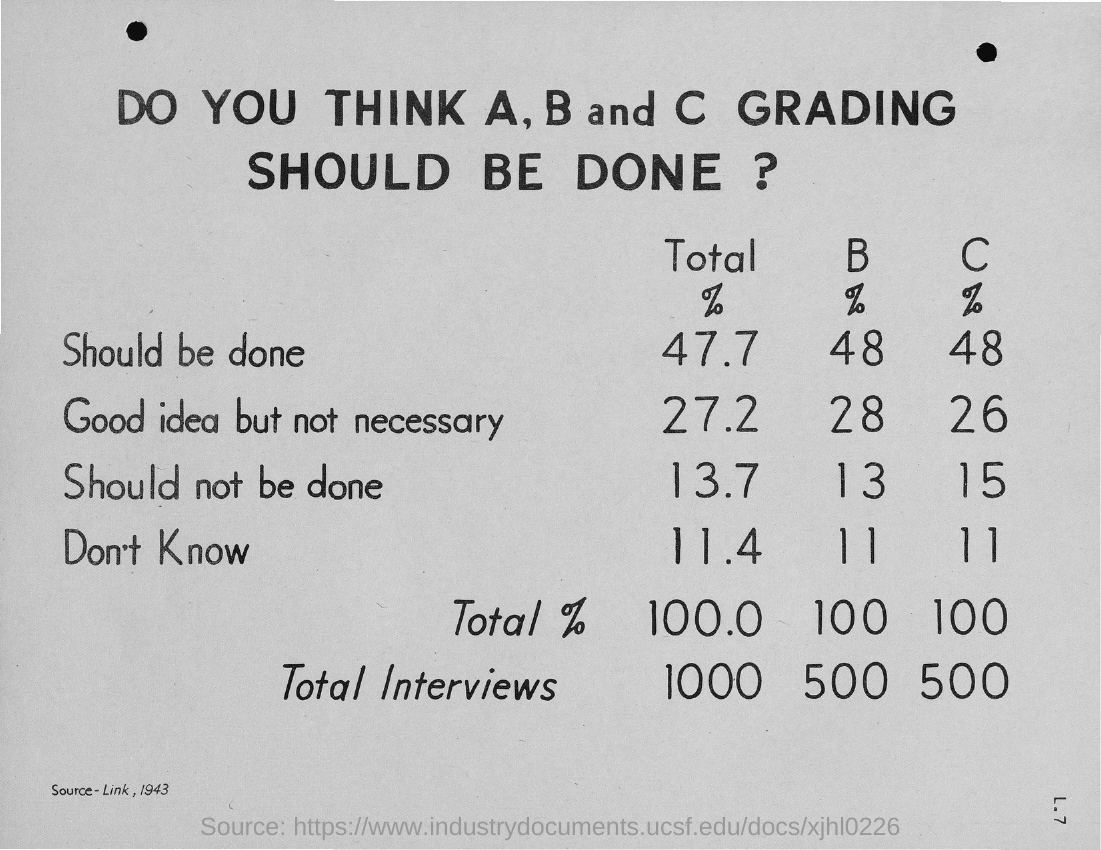Identify some key points in this picture. In the case of a C grade, approximately 11% of respondents selected the "Don't Know" option. Out of 100%, "Should not be done" accounts for approximately 15% in the case of a C grade. Out of the total B grade cases, 48% should be done. Out of the B grade cases, 28% were deemed to have a good idea but not necessarily necessary. 